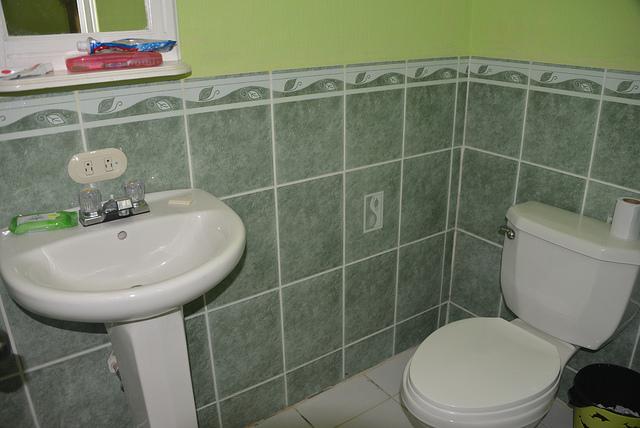How tall is the sink from the floor?
Answer briefly. 3 feet. What room is this?
Answer briefly. Bathroom. Is the lid to the trash can open?
Short answer required. No. Why is the wall two different colors?
Be succinct. Design. Is there an air freshener on top of the toilet?
Answer briefly. No. Does this toilet have buttons?
Keep it brief. No. 